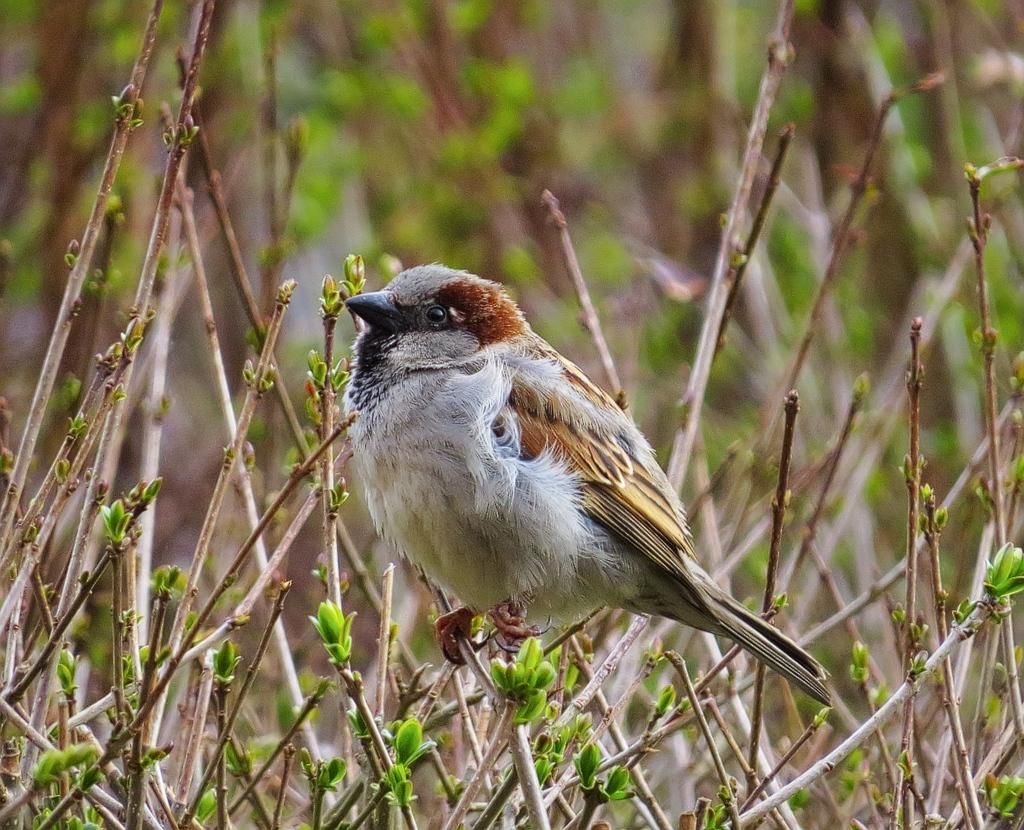What type of animal is in the image? There is a bird in the image. Where is the bird located in relation to the plant? The bird is on a stem of a plant. How is the bird positioned in the image? The bird is in the middle of the image. What type of straw is the bird using to cover its disease in the image? There is no straw, cover, or disease present in the image; it features a bird on a stem of a plant. 